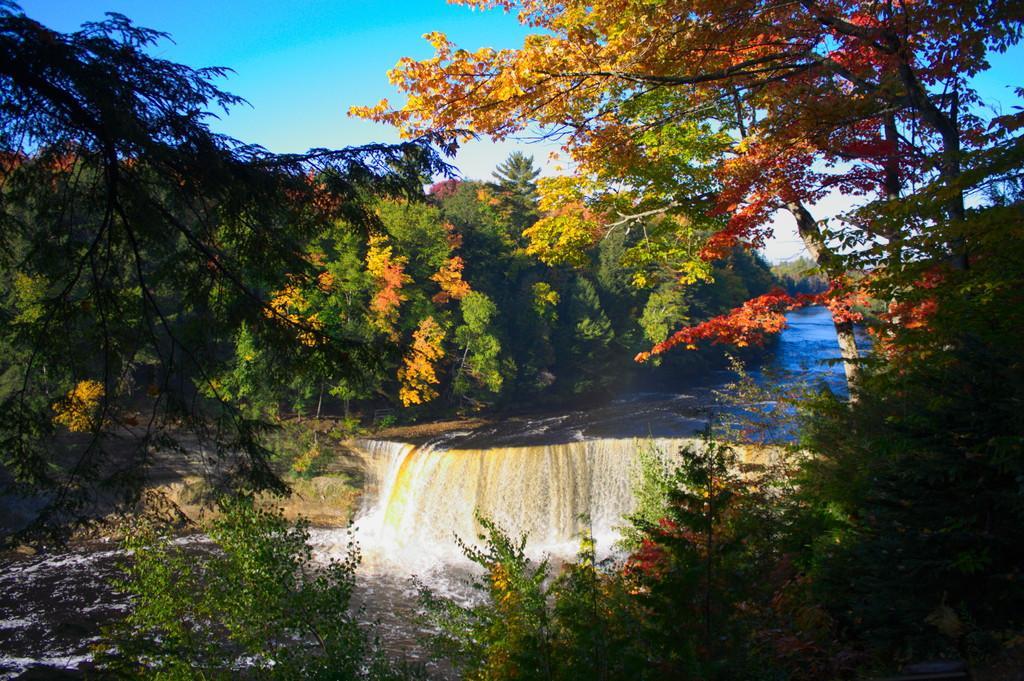Describe this image in one or two sentences. In this image I see the trees, water and the clear sky which is of blue and white in color. 